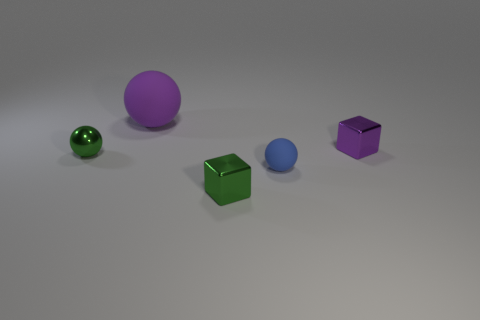There is a green shiny object that is the same size as the metallic sphere; what shape is it?
Provide a succinct answer. Cube. There is a metal block on the right side of the blue ball; is its size the same as the small green metal ball?
Offer a terse response. Yes. What is the material of the other block that is the same size as the green metal block?
Make the answer very short. Metal. Is there a tiny green sphere that is in front of the green thing that is behind the blue ball that is right of the green shiny block?
Ensure brevity in your answer.  No. Is there anything else that is the same shape as the blue matte object?
Offer a terse response. Yes. Does the small ball to the right of the tiny shiny sphere have the same color as the tiny shiny object left of the large object?
Provide a succinct answer. No. Is there a ball?
Provide a short and direct response. Yes. There is a small thing that is the same color as the big object; what is it made of?
Provide a succinct answer. Metal. How big is the metal object on the left side of the block that is left of the tiny metal cube behind the green metal cube?
Offer a terse response. Small. Does the blue thing have the same shape as the tiny shiny thing behind the small shiny ball?
Give a very brief answer. No. 